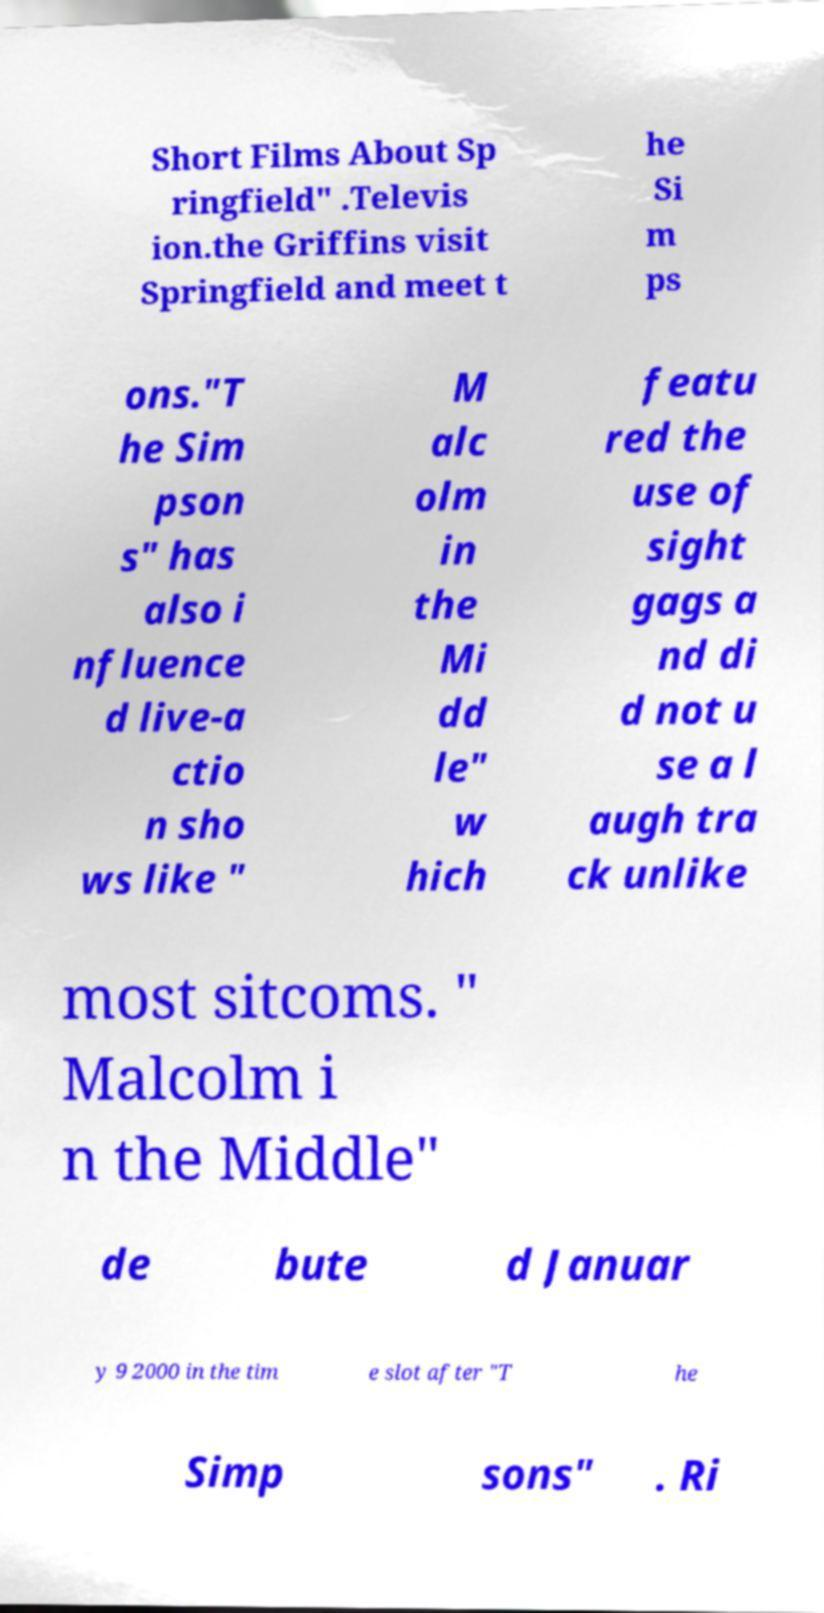Can you read and provide the text displayed in the image?This photo seems to have some interesting text. Can you extract and type it out for me? Short Films About Sp ringfield" .Televis ion.the Griffins visit Springfield and meet t he Si m ps ons."T he Sim pson s" has also i nfluence d live-a ctio n sho ws like " M alc olm in the Mi dd le" w hich featu red the use of sight gags a nd di d not u se a l augh tra ck unlike most sitcoms. " Malcolm i n the Middle" de bute d Januar y 9 2000 in the tim e slot after "T he Simp sons" . Ri 